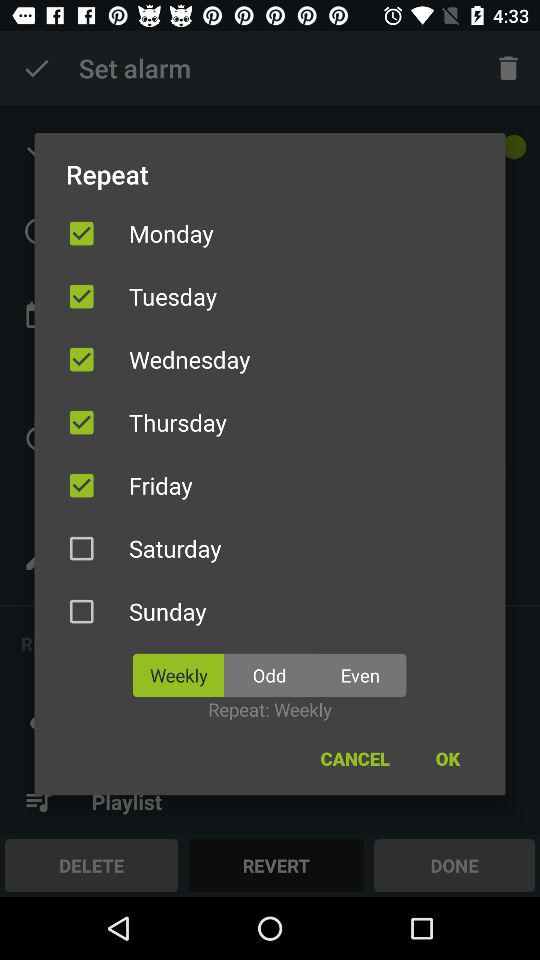What days are selected for repeating the alarm? The selected days are Monday, Tuesday, Wednesday, Thursday and Friday. 